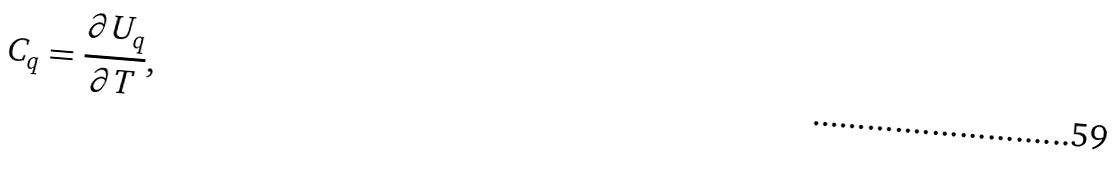<formula> <loc_0><loc_0><loc_500><loc_500>C _ { q } = \frac { \partial U _ { q } } { \partial T } ,</formula> 